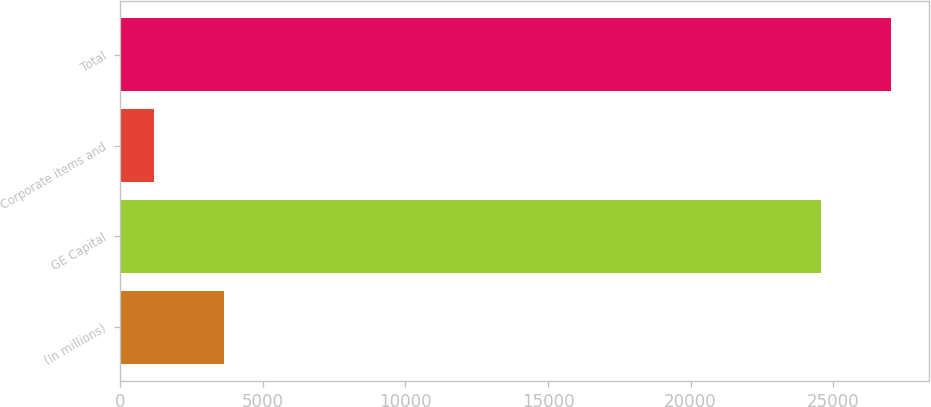Convert chart to OTSL. <chart><loc_0><loc_0><loc_500><loc_500><bar_chart><fcel>(In millions)<fcel>GE Capital<fcel>Corporate items and<fcel>Total<nl><fcel>3645<fcel>24570<fcel>1188<fcel>27027<nl></chart> 